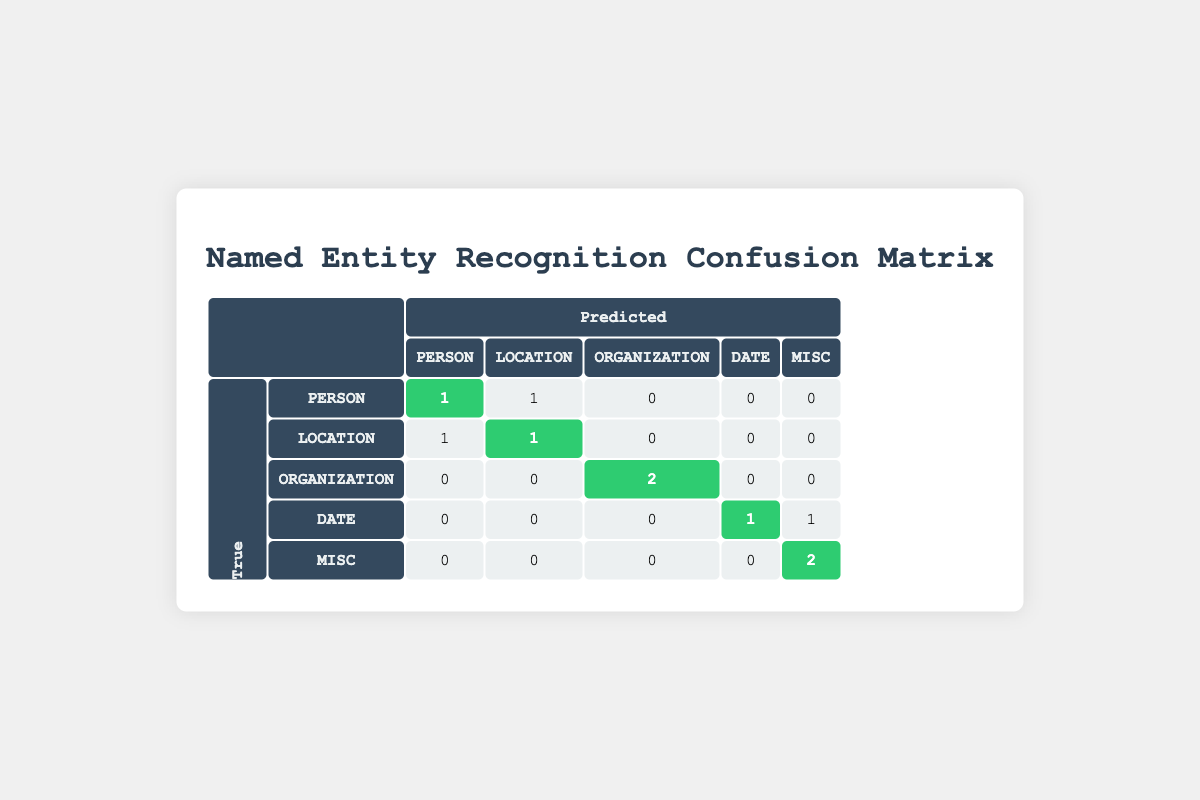What is the number of true positive predictions for the PERSON category? In the table, we look for the values in the row for the PERSON category and the column for PERSON in the predicted labels. The corresponding value is 1, indicating that there was 1 true positive for this category.
Answer: 1 How many true positive predictions are there for the ORGANIZATION category? Looking at the row for the ORGANIZATION category and the column for ORGANIZATION in the predicted labels, the value is 2. This indicates there were 2 correct predictions.
Answer: 2 Is the predicted label for "Eiffel Tower" classified correctly? In the data points, the true label for "Eiffel Tower" is found to be LOCATION, while its predicted label is Landmark, which is incorrect. Hence, the prediction was wrong.
Answer: No What is the total number of misclassifications for the MISC category? By examining the MISC row, the predictions for MISC that were not correctly classified in the predicted MISC column show a value of 0 in the off-diagonal cells. Therefore, there were no misclassifications; all instances were classified as MISC.
Answer: 0 How many total predictions were made for the LOCATION category? We need to add up both the true positives and the false negatives for the LOCATION category. The true positive is 1 (correctly classified) and the incorrect class predictions (1 from the PERSON category). Therefore, total predictions equal 2.
Answer: 2 How many entities were incorrectly classified as PERSON? To find this number, we look at the column for PERSON and sum the values in its respective row (excluding true positives). There is 1 incorrectly classified as LOCATION, thus the answer is 1.
Answer: 1 Was the prediction for "January 1, 2020" accurate? The prediction for "January 1, 2020" is examined in the data points. The true label is DATE and the predicted label is also DATE, showing that the prediction was accurate.
Answer: Yes What is the total count of predictions made for the DATE category? In the DATE row, the true positives (1) and the false predictions (1 for MISC) needs to be summed to understand total predictions. This results in a total of 2 predictions.
Answer: 2 How many unique categories were involved in misclassification? Looking across all rows and columns, the misclassified predictions were made for PERSON, LOCATION, and MISC. Thus, we can count the unique categories involved, which totals to 3.
Answer: 3 